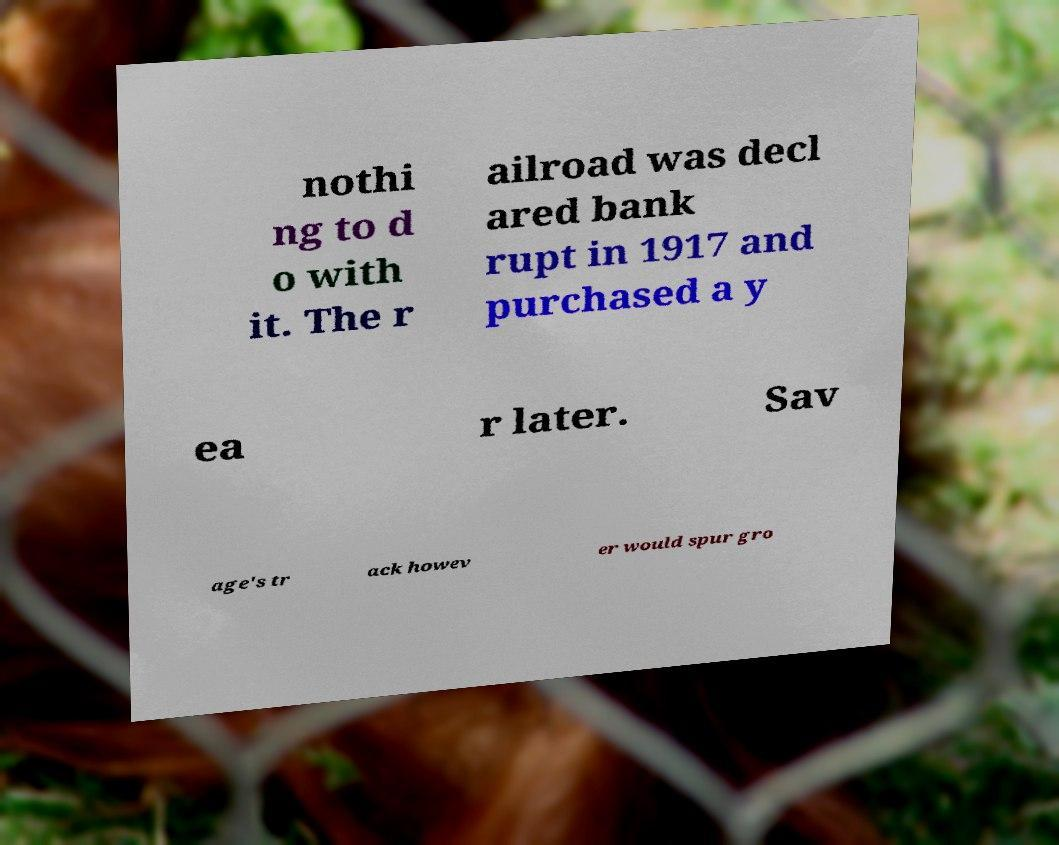Can you accurately transcribe the text from the provided image for me? nothi ng to d o with it. The r ailroad was decl ared bank rupt in 1917 and purchased a y ea r later. Sav age's tr ack howev er would spur gro 